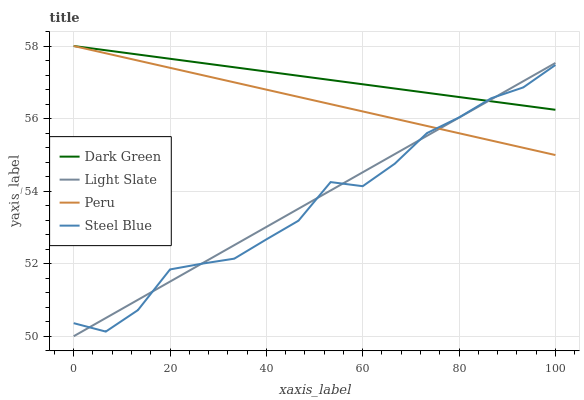Does Peru have the minimum area under the curve?
Answer yes or no. No. Does Peru have the maximum area under the curve?
Answer yes or no. No. Is Steel Blue the smoothest?
Answer yes or no. No. Is Peru the roughest?
Answer yes or no. No. Does Steel Blue have the lowest value?
Answer yes or no. No. Does Steel Blue have the highest value?
Answer yes or no. No. 